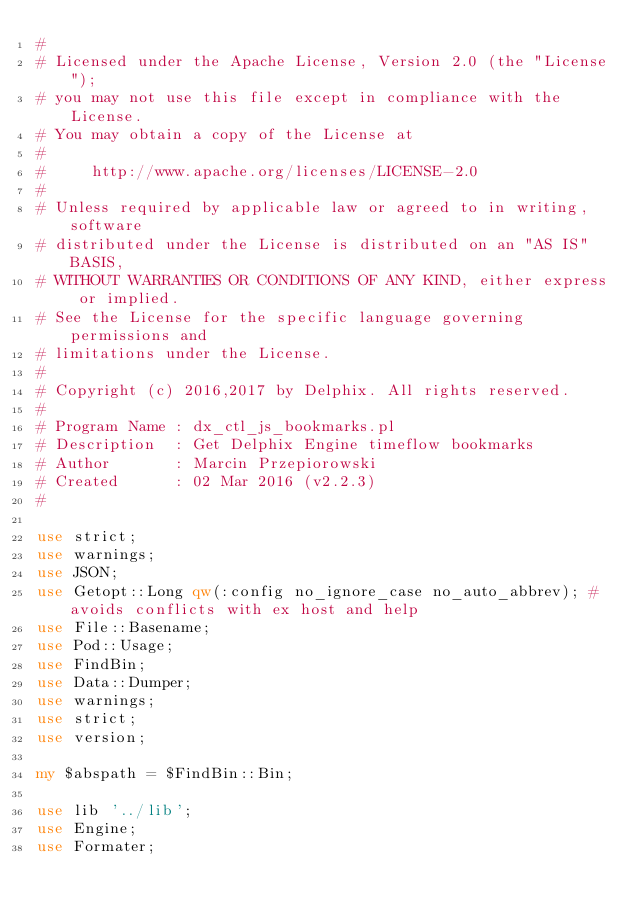<code> <loc_0><loc_0><loc_500><loc_500><_Perl_>#
# Licensed under the Apache License, Version 2.0 (the "License");
# you may not use this file except in compliance with the License.
# You may obtain a copy of the License at
#
#     http://www.apache.org/licenses/LICENSE-2.0
#
# Unless required by applicable law or agreed to in writing, software
# distributed under the License is distributed on an "AS IS" BASIS,
# WITHOUT WARRANTIES OR CONDITIONS OF ANY KIND, either express or implied.
# See the License for the specific language governing permissions and
# limitations under the License.
#
# Copyright (c) 2016,2017 by Delphix. All rights reserved.
#
# Program Name : dx_ctl_js_bookmarks.pl
# Description  : Get Delphix Engine timeflow bookmarks
# Author       : Marcin Przepiorowski
# Created      : 02 Mar 2016 (v2.2.3)
#

use strict;
use warnings;
use JSON;
use Getopt::Long qw(:config no_ignore_case no_auto_abbrev); #avoids conflicts with ex host and help
use File::Basename;
use Pod::Usage;
use FindBin;
use Data::Dumper;
use warnings;
use strict;
use version;

my $abspath = $FindBin::Bin;

use lib '../lib';
use Engine;
use Formater;</code> 